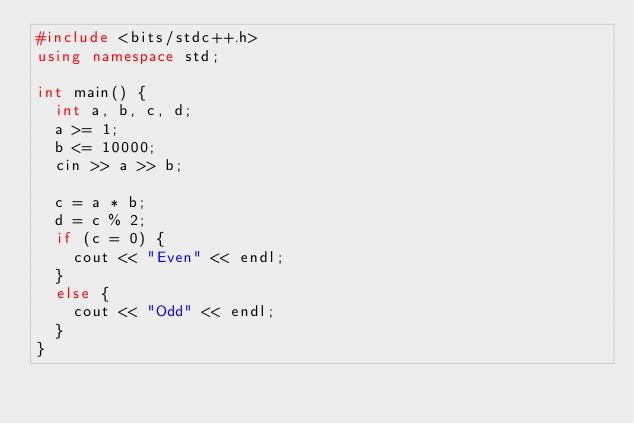Convert code to text. <code><loc_0><loc_0><loc_500><loc_500><_C++_>#include <bits/stdc++.h>
using namespace std;

int main() {
  int a, b, c, d;
  a >= 1;
  b <= 10000;
  cin >> a >> b;

  c = a * b;
  d = c % 2;
  if (c = 0) {
    cout << "Even" << endl;
  }
  else {
    cout << "Odd" << endl;
  }
}</code> 